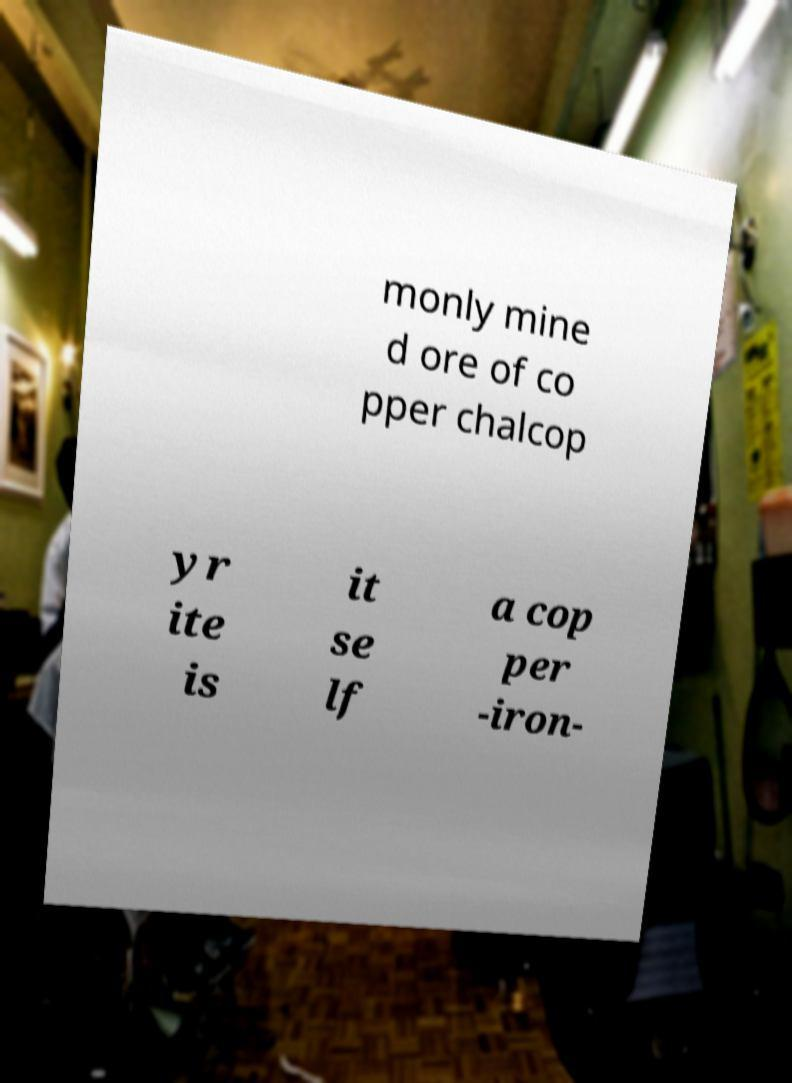What messages or text are displayed in this image? I need them in a readable, typed format. monly mine d ore of co pper chalcop yr ite is it se lf a cop per -iron- 